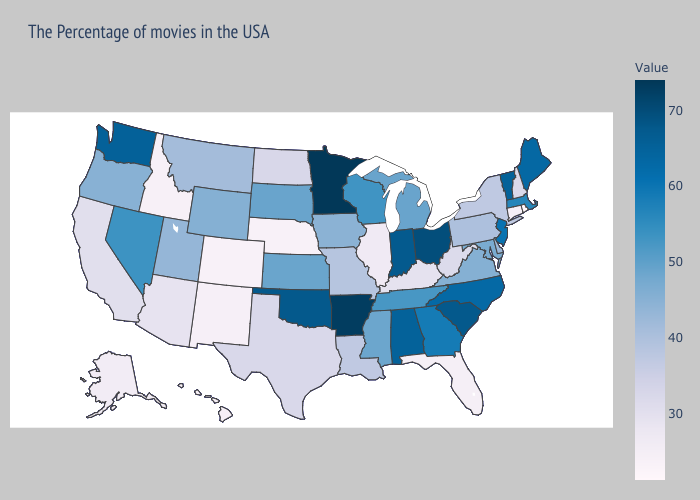Does West Virginia have a lower value than Colorado?
Be succinct. No. Among the states that border Florida , does Georgia have the lowest value?
Concise answer only. Yes. Which states have the lowest value in the MidWest?
Give a very brief answer. Nebraska. Does the map have missing data?
Concise answer only. No. Which states have the highest value in the USA?
Write a very short answer. Minnesota. 